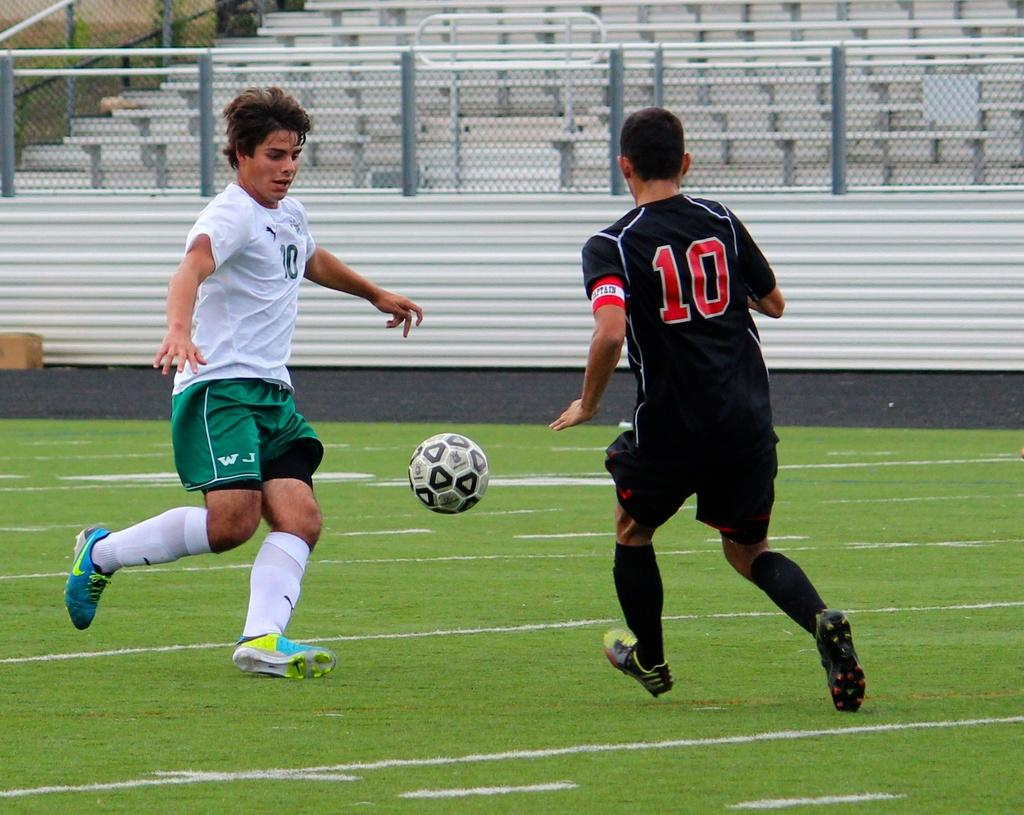<image>
Render a clear and concise summary of the photo. Player number 10 in a black uniform is going for the soccer ball. 